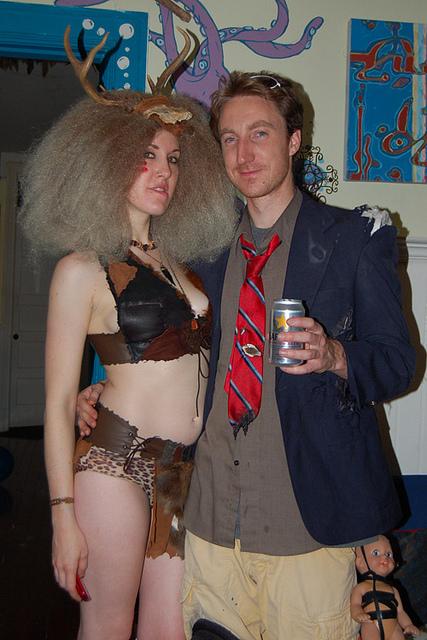Are they married?
Write a very short answer. No. What is the woman wearing on her head?
Short answer required. Antlers. What color are they?
Concise answer only. White. 